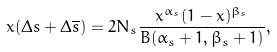<formula> <loc_0><loc_0><loc_500><loc_500>x ( \Delta s + \Delta \overline { s } ) = 2 N _ { s } \frac { x ^ { \alpha _ { s } } ( 1 - x ) ^ { \beta _ { s } } } { B ( \alpha _ { s } + 1 , \beta _ { s } + 1 ) } ,</formula> 